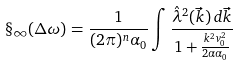Convert formula to latex. <formula><loc_0><loc_0><loc_500><loc_500>\S _ { \infty } ( \Delta \omega ) = \frac { 1 } { ( 2 \pi ) ^ { n } \alpha _ { 0 } } \int \frac { \hat { \lambda } ^ { 2 } ( \vec { k } ) \, d \vec { k } } { 1 + \frac { k ^ { 2 } v _ { 0 } ^ { 2 } } { 2 \alpha \alpha _ { 0 } } }</formula> 